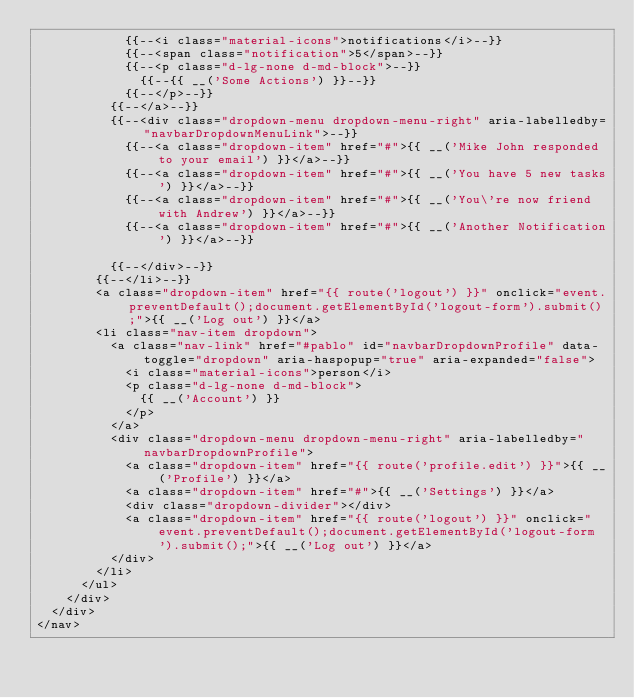Convert code to text. <code><loc_0><loc_0><loc_500><loc_500><_PHP_>            {{--<i class="material-icons">notifications</i>--}}
            {{--<span class="notification">5</span>--}}
            {{--<p class="d-lg-none d-md-block">--}}
              {{--{{ __('Some Actions') }}--}}
            {{--</p>--}}
          {{--</a>--}}
          {{--<div class="dropdown-menu dropdown-menu-right" aria-labelledby="navbarDropdownMenuLink">--}}
            {{--<a class="dropdown-item" href="#">{{ __('Mike John responded to your email') }}</a>--}}
            {{--<a class="dropdown-item" href="#">{{ __('You have 5 new tasks') }}</a>--}}
            {{--<a class="dropdown-item" href="#">{{ __('You\'re now friend with Andrew') }}</a>--}}
            {{--<a class="dropdown-item" href="#">{{ __('Another Notification') }}</a>--}}

          {{--</div>--}}
        {{--</li>--}}
        <a class="dropdown-item" href="{{ route('logout') }}" onclick="event.preventDefault();document.getElementById('logout-form').submit();">{{ __('Log out') }}</a>
        <li class="nav-item dropdown">
          <a class="nav-link" href="#pablo" id="navbarDropdownProfile" data-toggle="dropdown" aria-haspopup="true" aria-expanded="false">
            <i class="material-icons">person</i>
            <p class="d-lg-none d-md-block">
              {{ __('Account') }}
            </p>
          </a>
          <div class="dropdown-menu dropdown-menu-right" aria-labelledby="navbarDropdownProfile">
            <a class="dropdown-item" href="{{ route('profile.edit') }}">{{ __('Profile') }}</a>
            <a class="dropdown-item" href="#">{{ __('Settings') }}</a>
            <div class="dropdown-divider"></div>
            <a class="dropdown-item" href="{{ route('logout') }}" onclick="event.preventDefault();document.getElementById('logout-form').submit();">{{ __('Log out') }}</a>
          </div>
        </li>
      </ul>
    </div>
  </div>
</nav>
</code> 